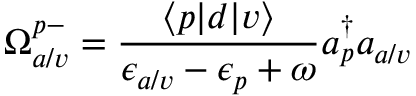Convert formula to latex. <formula><loc_0><loc_0><loc_500><loc_500>\Omega _ { a / v } ^ { p - } = \frac { \langle p | d | v \rangle } { \epsilon _ { a / v } - \epsilon _ { p } + \omega } a _ { p } ^ { \dagger } a _ { a / v }</formula> 